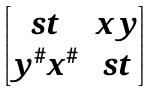<formula> <loc_0><loc_0><loc_500><loc_500>\begin{bmatrix} s t & x y \\ y ^ { \# } x ^ { \# } & s t \end{bmatrix}</formula> 